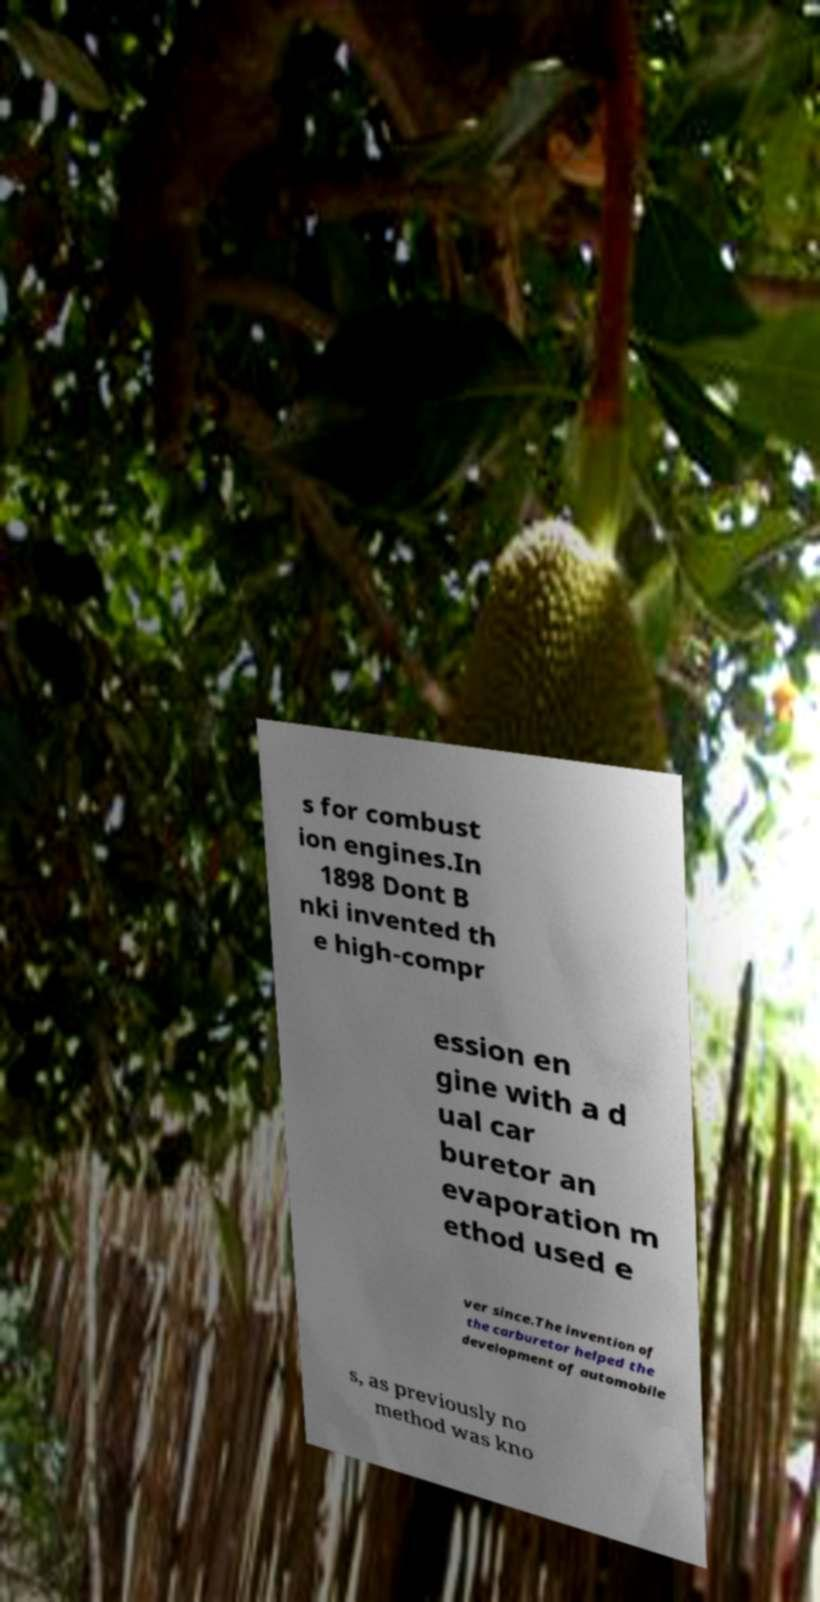Could you assist in decoding the text presented in this image and type it out clearly? s for combust ion engines.In 1898 Dont B nki invented th e high-compr ession en gine with a d ual car buretor an evaporation m ethod used e ver since.The invention of the carburetor helped the development of automobile s, as previously no method was kno 